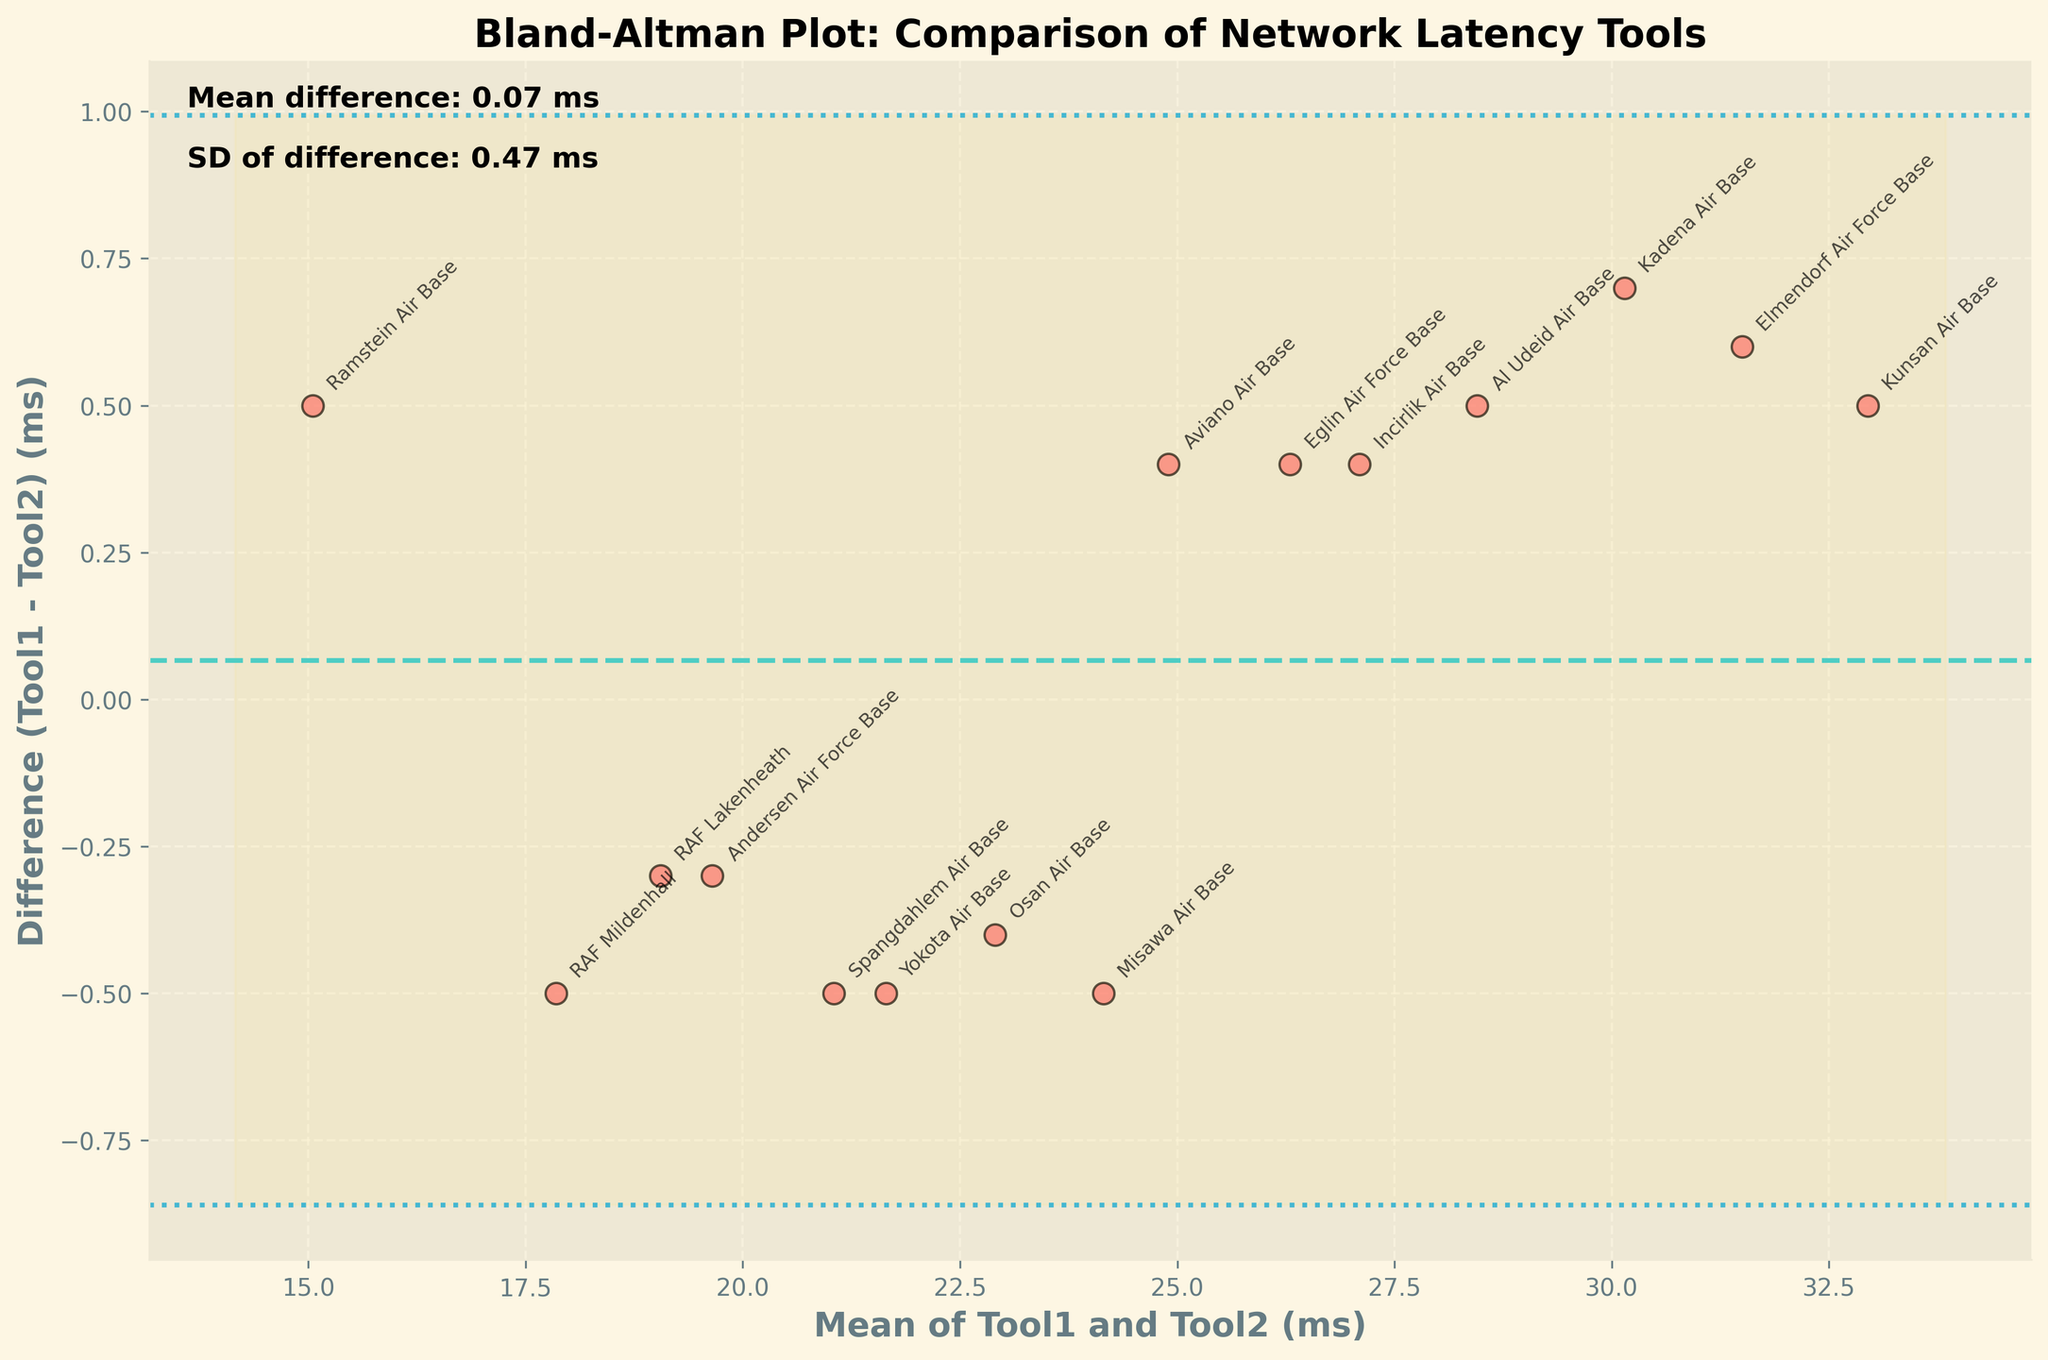What is the title of the plot? The title of the plot is generally the most prominently displayed text at the top of the figure. It describes the purpose of the visualization for the viewer.
Answer: Bland-Altman Plot: Comparison of Network Latency Tools What does the y-axis represent? The y-axis label explains what the vertical axis of the plot measures. Here, it denotes the difference in network latency measurements between two monitoring tools.
Answer: Difference (Tool1 - Tool2) (ms) How many data points are plotted in the figure? The number of data points can be counted from the individual markers shown on the plot. Each marker represents a base's network latency measurement difference between the two tools.
Answer: 15 What bases show the highest and lowest mean latency differences between Tool1 and Tool2? By looking at the scatter points on the plot, the extremes in the differences (highest and lowest positions on y-axis) can be identified, and noting corresponding bases.
Answer: Kunsan Air Base (highest), Ramstein Air Base (lowest) What is the mean difference of the latency measurements between Tool1 and Tool2? The mean difference is typically indicated by a horizontal line across the plot with a specific color and labeled accordingly.
Answer: Approximately 0.37 ms How does the standard deviation (SD) of the differences help interpret the plot? The SD indicates the typical spread or variation of the differences from the mean. Axhlines mark the limits where 'mean ± 1.96 * SD' showing acceptable error bounds. These areas can help assess the agreement's extent.
Answer: It helps to identify the consistency between two tools Which base had the closest latency measurements between Tool1 and Tool2? By observing data points lying closest to the y-axis (difference = 0.0 ms), the corresponding bases showing minimal difference can be identified.
Answer: Incirlik Air Base Which data points fall outside the 'mean ± 1.96 * SD' range, indicating potential outliers? Points lying outside these horizontal boundaries are considered outliers. Observe these boundary lines and note the points beyond them.
Answer: No data points fall outside this range Are there more positive or negative differences between Tool1 and Tool2 measurements? Positive or negative differences can be determined by counting points above and below the mean difference line respectively.
Answer: More negative differences What does the filled yellow area in the plot represent? The filled yellow area provides a visual of the region between 'mean ± 1.96 * SD', illustrating acceptable variability in measurement differences.
Answer: Acceptable limits of agreement (variability) 